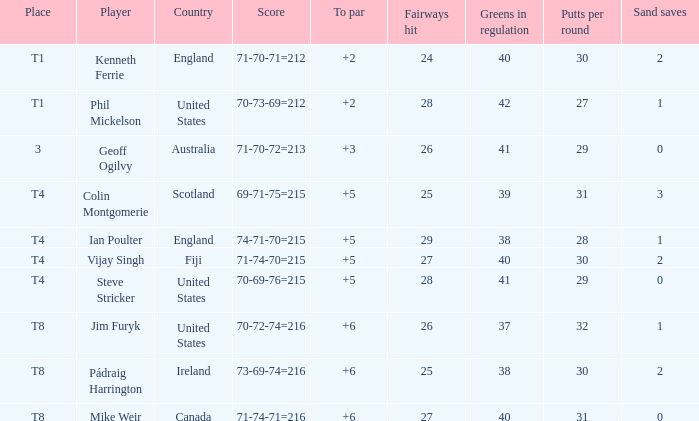Who had a score of 70-73-69=212? Phil Mickelson. 